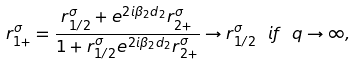Convert formula to latex. <formula><loc_0><loc_0><loc_500><loc_500>r _ { 1 + } ^ { \sigma } = \frac { r _ { 1 / 2 } ^ { \sigma } + e ^ { 2 i \beta _ { 2 } d _ { 2 } } r _ { 2 + } ^ { \sigma } } { 1 + r _ { 1 / 2 } ^ { \sigma } e ^ { 2 i \beta _ { 2 } d _ { 2 } } r _ { 2 + } ^ { \sigma } } \to r _ { 1 / 2 } ^ { \sigma } \ i f \ q \to \infty ,</formula> 